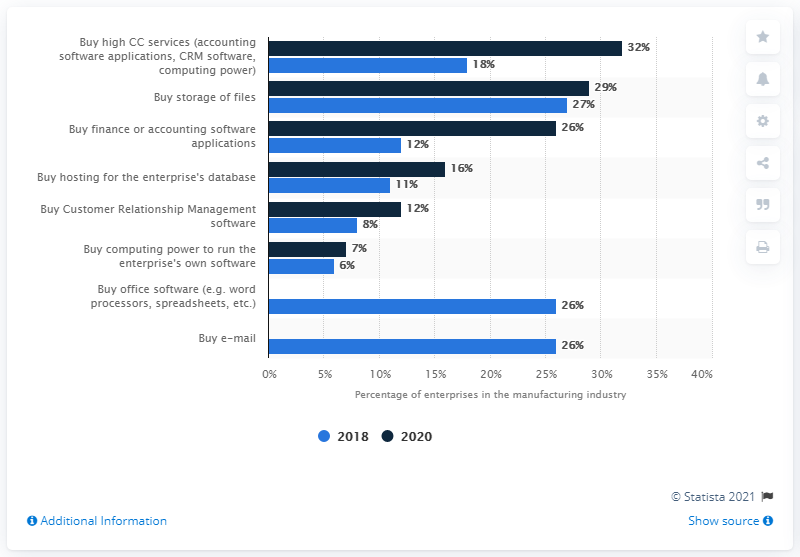Outline some significant characteristics in this image. In 2020, approximately 32% of businesses in the UK manufacturing industry with over 10 employees purchased Cloud Computing services. In 2018, a significant percentage of enterprises purchased cloud computing services. 